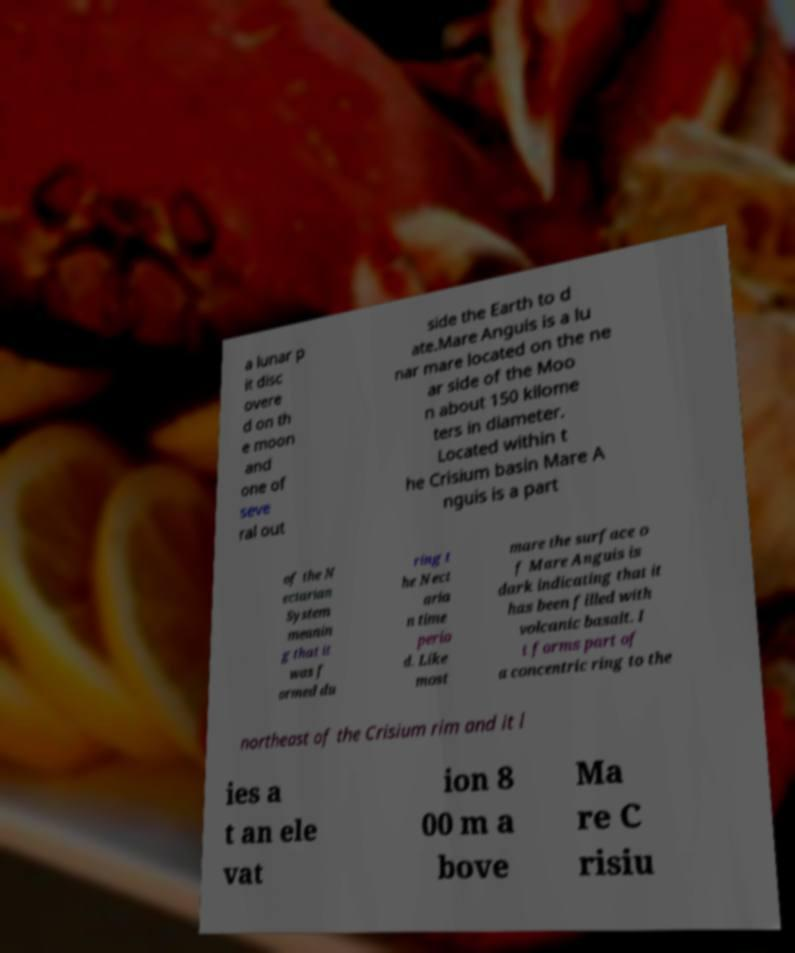For documentation purposes, I need the text within this image transcribed. Could you provide that? a lunar p it disc overe d on th e moon and one of seve ral out side the Earth to d ate.Mare Anguis is a lu nar mare located on the ne ar side of the Moo n about 150 kilome ters in diameter. Located within t he Crisium basin Mare A nguis is a part of the N ectarian System meanin g that it was f ormed du ring t he Nect aria n time perio d. Like most mare the surface o f Mare Anguis is dark indicating that it has been filled with volcanic basalt. I t forms part of a concentric ring to the northeast of the Crisium rim and it l ies a t an ele vat ion 8 00 m a bove Ma re C risiu 